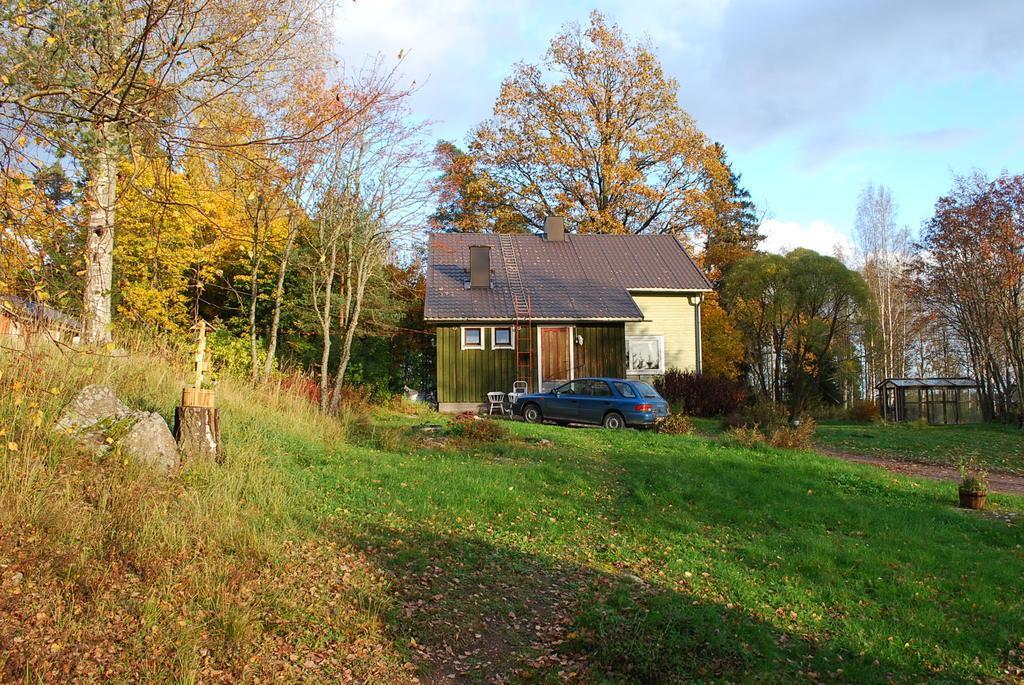Please provide a concise description of this image. There is a wooden house in a garden and in front of the house there is a car and two chairs, there are a lot of trees around the the house and on the right side there is a small empty shed and in the background there is a sky. 